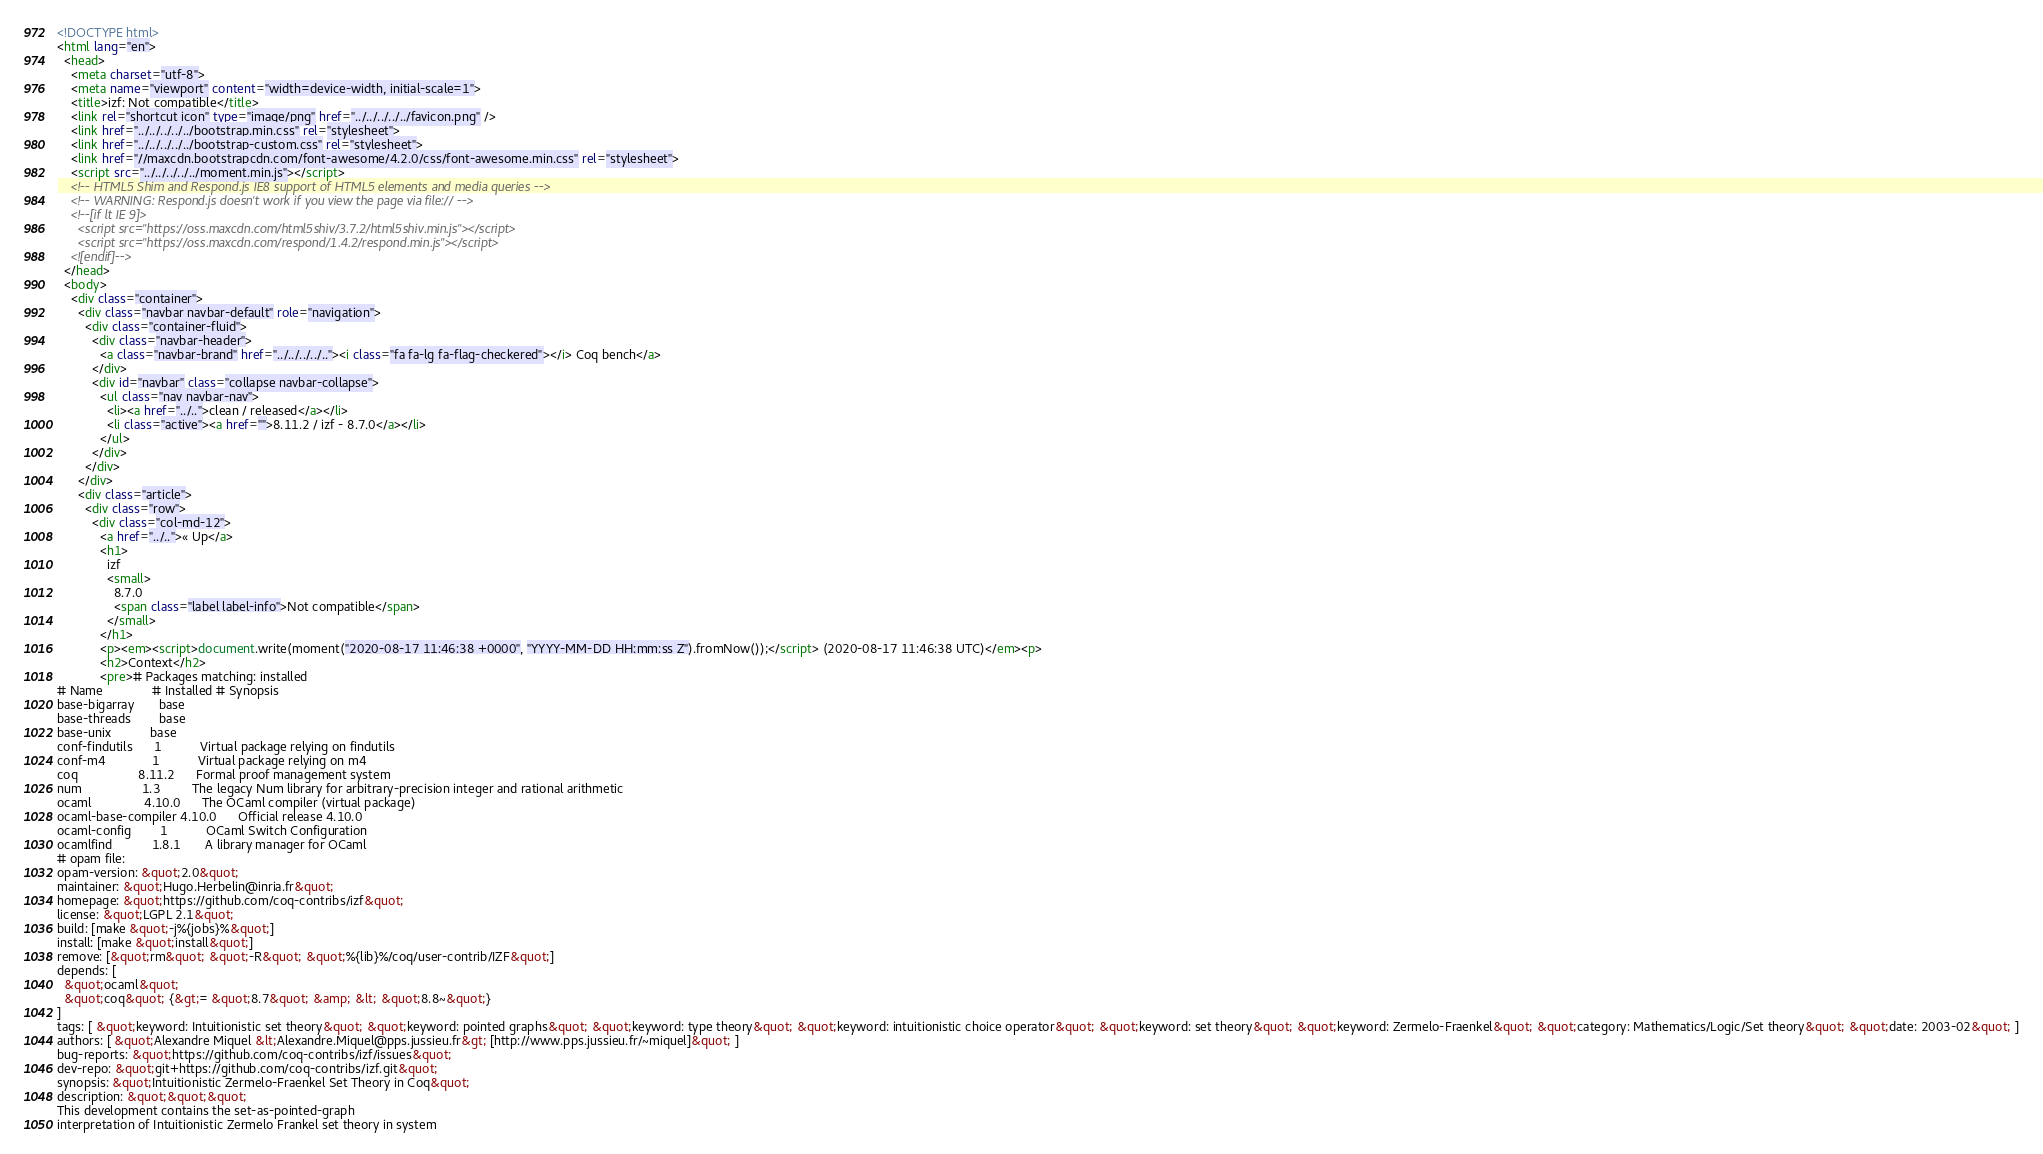Convert code to text. <code><loc_0><loc_0><loc_500><loc_500><_HTML_><!DOCTYPE html>
<html lang="en">
  <head>
    <meta charset="utf-8">
    <meta name="viewport" content="width=device-width, initial-scale=1">
    <title>izf: Not compatible</title>
    <link rel="shortcut icon" type="image/png" href="../../../../../favicon.png" />
    <link href="../../../../../bootstrap.min.css" rel="stylesheet">
    <link href="../../../../../bootstrap-custom.css" rel="stylesheet">
    <link href="//maxcdn.bootstrapcdn.com/font-awesome/4.2.0/css/font-awesome.min.css" rel="stylesheet">
    <script src="../../../../../moment.min.js"></script>
    <!-- HTML5 Shim and Respond.js IE8 support of HTML5 elements and media queries -->
    <!-- WARNING: Respond.js doesn't work if you view the page via file:// -->
    <!--[if lt IE 9]>
      <script src="https://oss.maxcdn.com/html5shiv/3.7.2/html5shiv.min.js"></script>
      <script src="https://oss.maxcdn.com/respond/1.4.2/respond.min.js"></script>
    <![endif]-->
  </head>
  <body>
    <div class="container">
      <div class="navbar navbar-default" role="navigation">
        <div class="container-fluid">
          <div class="navbar-header">
            <a class="navbar-brand" href="../../../../.."><i class="fa fa-lg fa-flag-checkered"></i> Coq bench</a>
          </div>
          <div id="navbar" class="collapse navbar-collapse">
            <ul class="nav navbar-nav">
              <li><a href="../..">clean / released</a></li>
              <li class="active"><a href="">8.11.2 / izf - 8.7.0</a></li>
            </ul>
          </div>
        </div>
      </div>
      <div class="article">
        <div class="row">
          <div class="col-md-12">
            <a href="../..">« Up</a>
            <h1>
              izf
              <small>
                8.7.0
                <span class="label label-info">Not compatible</span>
              </small>
            </h1>
            <p><em><script>document.write(moment("2020-08-17 11:46:38 +0000", "YYYY-MM-DD HH:mm:ss Z").fromNow());</script> (2020-08-17 11:46:38 UTC)</em><p>
            <h2>Context</h2>
            <pre># Packages matching: installed
# Name              # Installed # Synopsis
base-bigarray       base
base-threads        base
base-unix           base
conf-findutils      1           Virtual package relying on findutils
conf-m4             1           Virtual package relying on m4
coq                 8.11.2      Formal proof management system
num                 1.3         The legacy Num library for arbitrary-precision integer and rational arithmetic
ocaml               4.10.0      The OCaml compiler (virtual package)
ocaml-base-compiler 4.10.0      Official release 4.10.0
ocaml-config        1           OCaml Switch Configuration
ocamlfind           1.8.1       A library manager for OCaml
# opam file:
opam-version: &quot;2.0&quot;
maintainer: &quot;Hugo.Herbelin@inria.fr&quot;
homepage: &quot;https://github.com/coq-contribs/izf&quot;
license: &quot;LGPL 2.1&quot;
build: [make &quot;-j%{jobs}%&quot;]
install: [make &quot;install&quot;]
remove: [&quot;rm&quot; &quot;-R&quot; &quot;%{lib}%/coq/user-contrib/IZF&quot;]
depends: [
  &quot;ocaml&quot;
  &quot;coq&quot; {&gt;= &quot;8.7&quot; &amp; &lt; &quot;8.8~&quot;}
]
tags: [ &quot;keyword: Intuitionistic set theory&quot; &quot;keyword: pointed graphs&quot; &quot;keyword: type theory&quot; &quot;keyword: intuitionistic choice operator&quot; &quot;keyword: set theory&quot; &quot;keyword: Zermelo-Fraenkel&quot; &quot;category: Mathematics/Logic/Set theory&quot; &quot;date: 2003-02&quot; ]
authors: [ &quot;Alexandre Miquel &lt;Alexandre.Miquel@pps.jussieu.fr&gt; [http://www.pps.jussieu.fr/~miquel]&quot; ]
bug-reports: &quot;https://github.com/coq-contribs/izf/issues&quot;
dev-repo: &quot;git+https://github.com/coq-contribs/izf.git&quot;
synopsis: &quot;Intuitionistic Zermelo-Fraenkel Set Theory in Coq&quot;
description: &quot;&quot;&quot;
This development contains the set-as-pointed-graph
interpretation of Intuitionistic Zermelo Frankel set theory in system</code> 